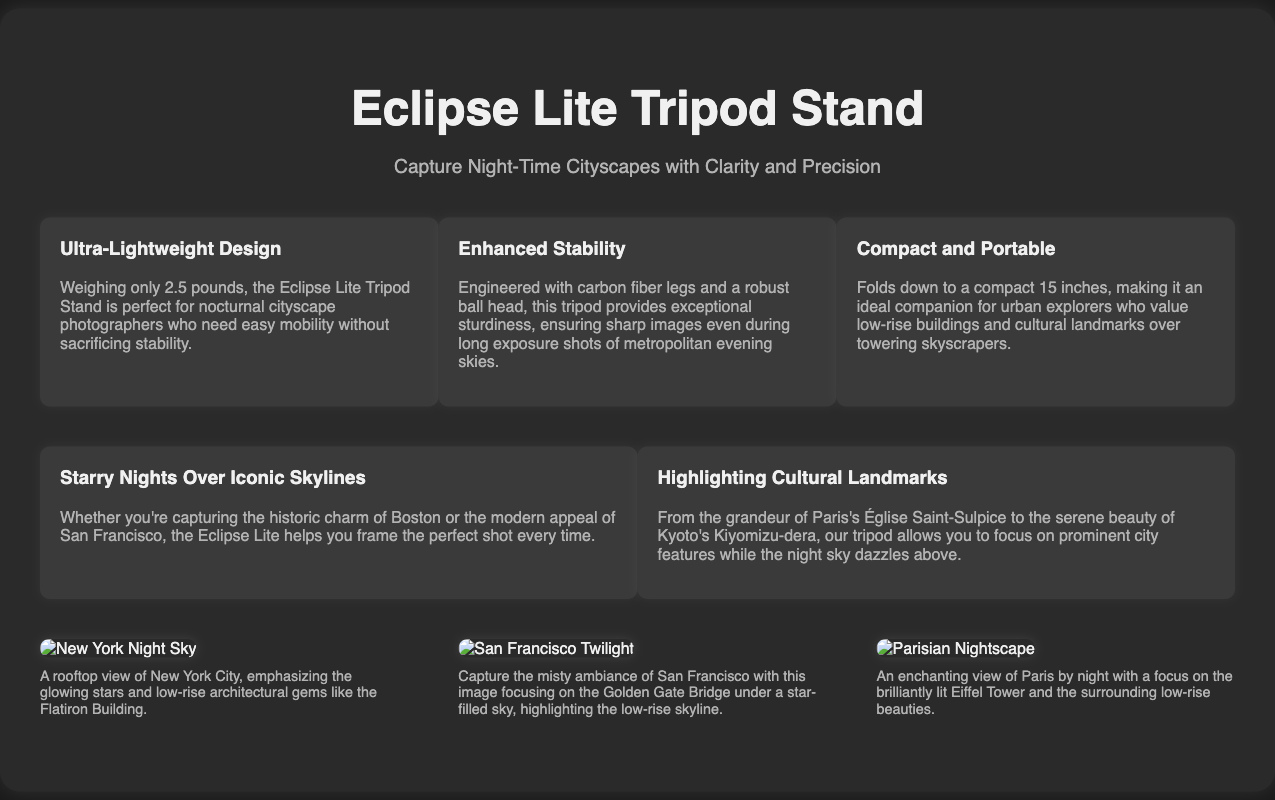What is the weight of the Eclipse Lite Tripod Stand? The weight of the tripod is mentioned in the features section, stating it weighs only 2.5 pounds.
Answer: 2.5 pounds What type of legs does the tripod have? The document specifies that the tripod has carbon fiber legs, which contributes to its sturdiness.
Answer: Carbon fiber What is the compact size of the tripod when folded? The promotional description highlights that the tripod folds down to a compact 15 inches.
Answer: 15 inches Which city is highlighted for its historic charm? The promo section refers to Boston as an example of a city with historic charm that can be captured using the tripod.
Answer: Boston What landmark is used to illustrate the highlight of cultural landmarks? The document mentions Paris's Église Saint-Sulpice as a prominent cultural landmark to be captured.
Answer: Église Saint-Sulpice How many features are presented for the tripod? The features section lists three distinct features about the tripod design.
Answer: Three What type of photography is the Eclipse Lite designed for? The tagline and product description indicates that the tripod is designed for night-time cityscape photography.
Answer: Night-time cityscape photography Which body of water is associated with the San Francisco image? The description of the San Francisco twilight image mentions the Golden Gate Bridge, which spans a significant body of water.
Answer: Golden Gate Bridge 